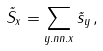<formula> <loc_0><loc_0><loc_500><loc_500>\vec { S } _ { x } = \sum _ { y . n n . x } \vec { s } _ { y } \, ,</formula> 